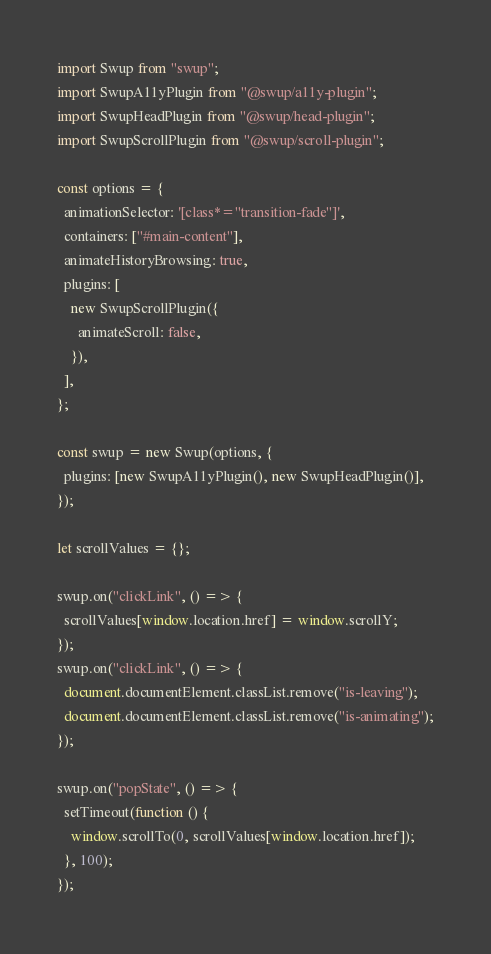Convert code to text. <code><loc_0><loc_0><loc_500><loc_500><_JavaScript_>import Swup from "swup";
import SwupA11yPlugin from "@swup/a11y-plugin";
import SwupHeadPlugin from "@swup/head-plugin";
import SwupScrollPlugin from "@swup/scroll-plugin";

const options = {
  animationSelector: '[class*="transition-fade"]',
  containers: ["#main-content"],
  animateHistoryBrowsing: true,
  plugins: [
    new SwupScrollPlugin({
      animateScroll: false,
    }),
  ],
};

const swup = new Swup(options, {
  plugins: [new SwupA11yPlugin(), new SwupHeadPlugin()],
});

let scrollValues = {};

swup.on("clickLink", () => {
  scrollValues[window.location.href] = window.scrollY;
});
swup.on("clickLink", () => {
  document.documentElement.classList.remove("is-leaving");
  document.documentElement.classList.remove("is-animating");
});

swup.on("popState", () => {
  setTimeout(function () {
    window.scrollTo(0, scrollValues[window.location.href]);
  }, 100);
});
</code> 